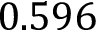Convert formula to latex. <formula><loc_0><loc_0><loc_500><loc_500>0 . 5 9 6</formula> 